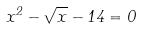<formula> <loc_0><loc_0><loc_500><loc_500>x ^ { 2 } - \sqrt { x } - 1 4 = 0</formula> 